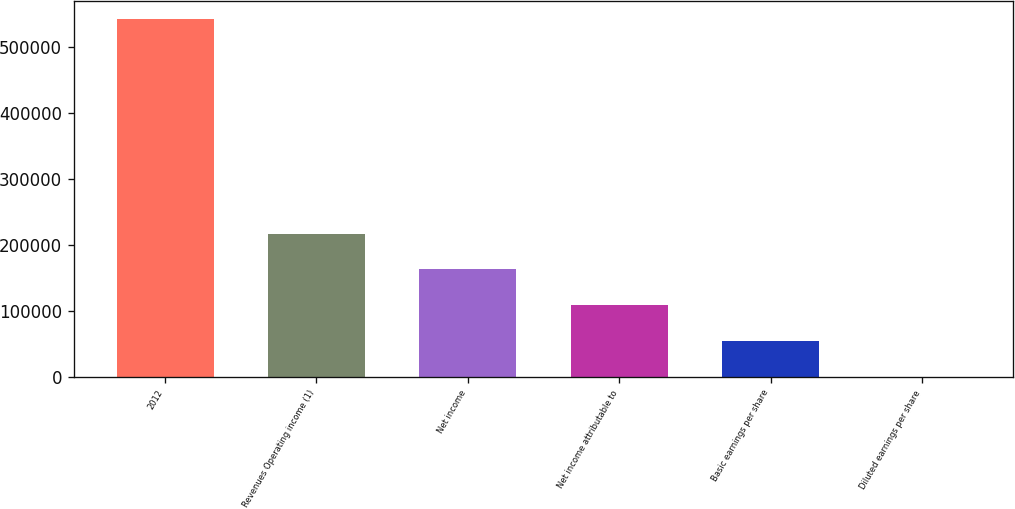Convert chart to OTSL. <chart><loc_0><loc_0><loc_500><loc_500><bar_chart><fcel>2012<fcel>Revenues Operating income (1)<fcel>Net income<fcel>Net income attributable to<fcel>Basic earnings per share<fcel>Diluted earnings per share<nl><fcel>542771<fcel>217109<fcel>162832<fcel>108555<fcel>54277.8<fcel>0.79<nl></chart> 